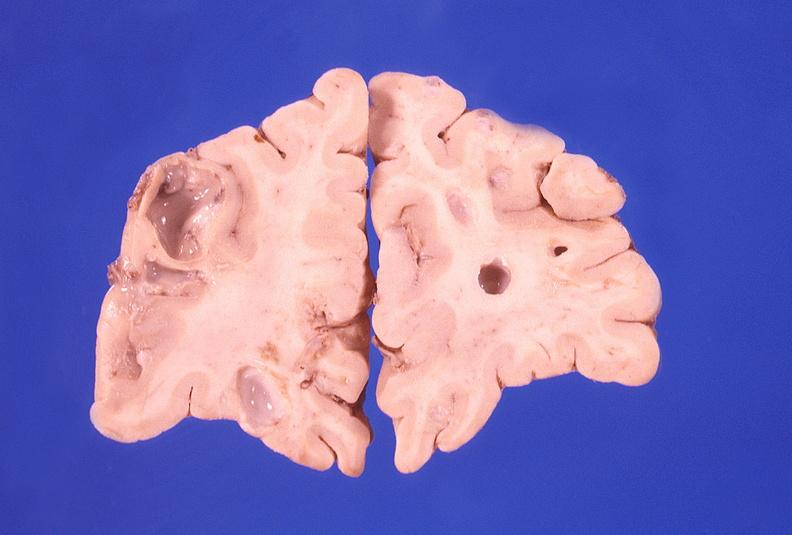what is present?
Answer the question using a single word or phrase. Nervous 